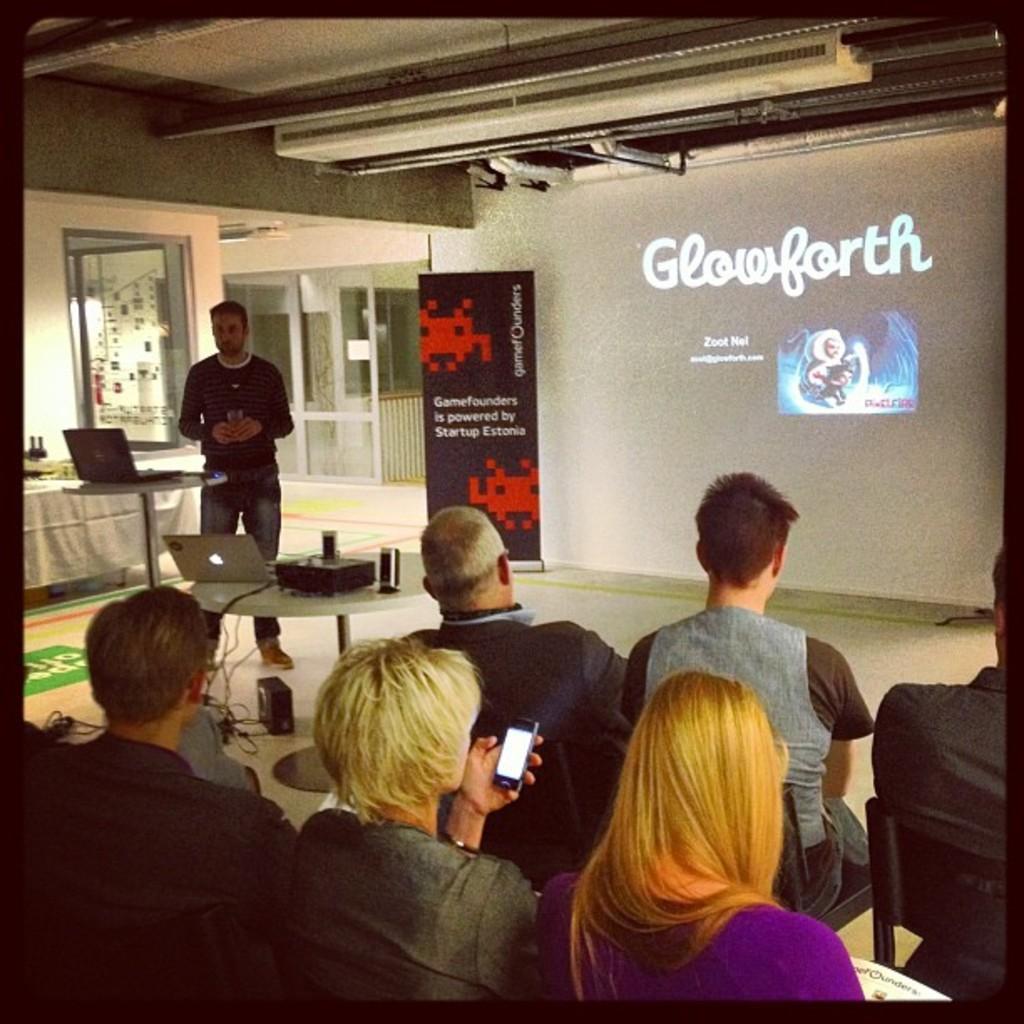Please provide a concise description of this image. In this image we can see the people sitting on the chairs. We can also see a man holding the glass and standing on the floor. We can also see the laptops and some other objects on the table. There is a woman holding the phone. In the background we can see the display screen with the text and at the top we can see the ceiling. The image has borders. 